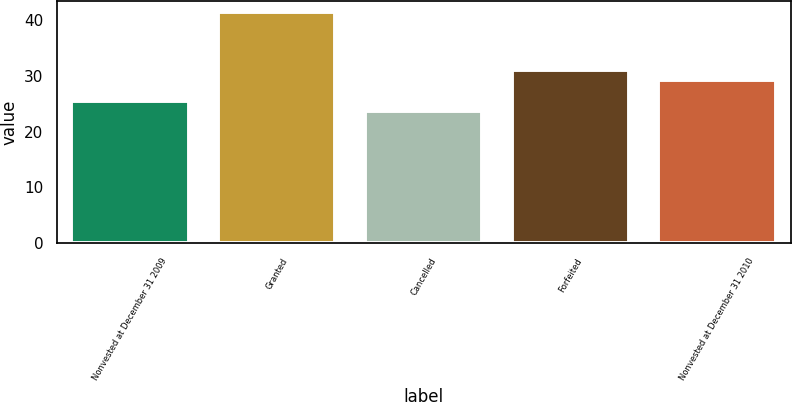Convert chart. <chart><loc_0><loc_0><loc_500><loc_500><bar_chart><fcel>Nonvested at December 31 2009<fcel>Granted<fcel>Cancelled<fcel>Forfeited<fcel>Nonvested at December 31 2010<nl><fcel>25.4<fcel>41.34<fcel>23.63<fcel>30.96<fcel>29.19<nl></chart> 